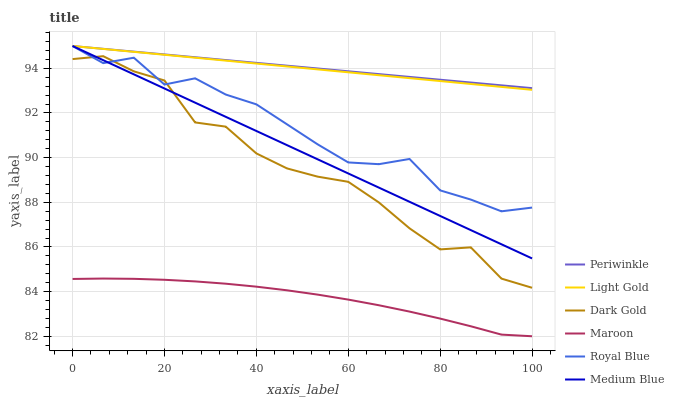Does Medium Blue have the minimum area under the curve?
Answer yes or no. No. Does Medium Blue have the maximum area under the curve?
Answer yes or no. No. Is Medium Blue the smoothest?
Answer yes or no. No. Is Medium Blue the roughest?
Answer yes or no. No. Does Medium Blue have the lowest value?
Answer yes or no. No. Does Maroon have the highest value?
Answer yes or no. No. Is Maroon less than Medium Blue?
Answer yes or no. Yes. Is Royal Blue greater than Maroon?
Answer yes or no. Yes. Does Maroon intersect Medium Blue?
Answer yes or no. No. 